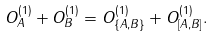Convert formula to latex. <formula><loc_0><loc_0><loc_500><loc_500>O _ { A } ^ { ( 1 ) } + O _ { B } ^ { ( 1 ) } = O _ { \{ A , B \} } ^ { ( 1 ) } + O _ { [ A , B ] } ^ { ( 1 ) } .</formula> 